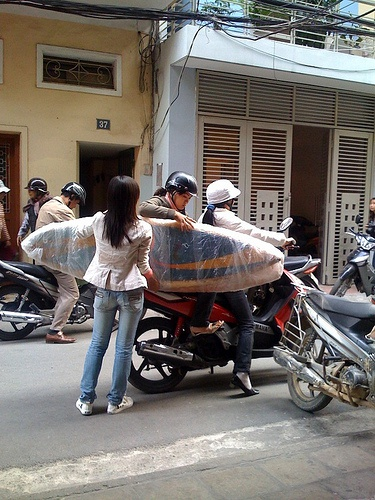Describe the objects in this image and their specific colors. I can see motorcycle in black, gray, darkgray, and lightgray tones, surfboard in black, gray, white, and darkgray tones, people in black, gray, lightgray, and darkgray tones, motorcycle in black, maroon, gray, and lightgray tones, and motorcycle in black, gray, darkgray, and white tones in this image. 